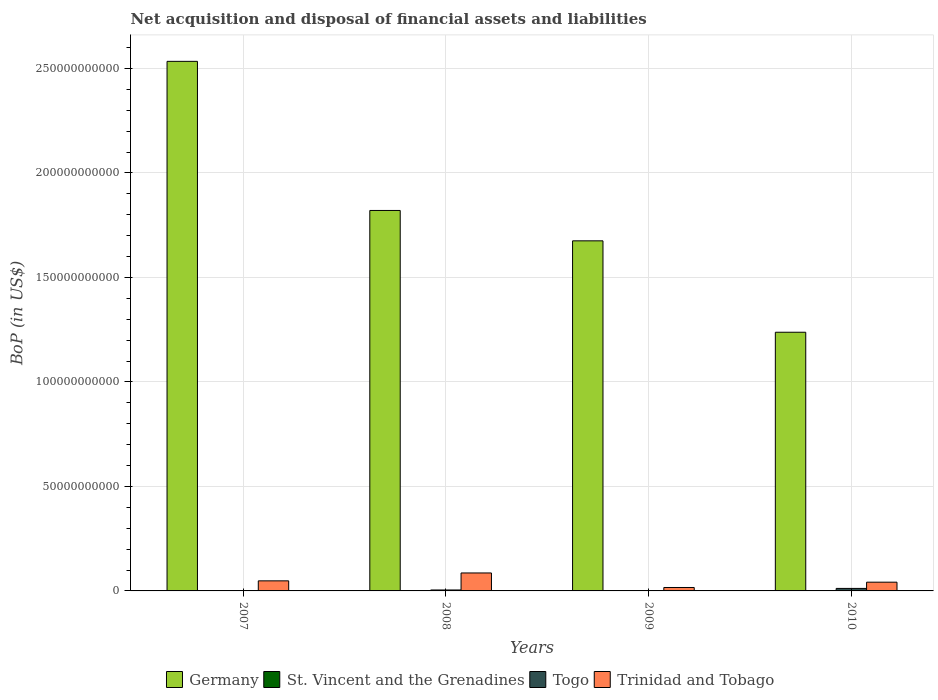Are the number of bars on each tick of the X-axis equal?
Offer a terse response. No. How many bars are there on the 3rd tick from the left?
Make the answer very short. 2. Across all years, what is the maximum Balance of Payments in Trinidad and Tobago?
Provide a short and direct response. 8.60e+09. Across all years, what is the minimum Balance of Payments in St. Vincent and the Grenadines?
Ensure brevity in your answer.  0. In which year was the Balance of Payments in Trinidad and Tobago maximum?
Offer a very short reply. 2008. What is the total Balance of Payments in Togo in the graph?
Make the answer very short. 1.65e+09. What is the difference between the Balance of Payments in Trinidad and Tobago in 2007 and that in 2008?
Give a very brief answer. -3.77e+09. What is the difference between the Balance of Payments in Togo in 2007 and the Balance of Payments in Germany in 2008?
Offer a terse response. -1.82e+11. What is the average Balance of Payments in Togo per year?
Provide a succinct answer. 4.13e+08. In the year 2008, what is the difference between the Balance of Payments in Togo and Balance of Payments in Trinidad and Tobago?
Make the answer very short. -8.14e+09. In how many years, is the Balance of Payments in Trinidad and Tobago greater than 60000000000 US$?
Give a very brief answer. 0. What is the ratio of the Balance of Payments in Germany in 2008 to that in 2009?
Provide a succinct answer. 1.09. What is the difference between the highest and the second highest Balance of Payments in Germany?
Offer a terse response. 7.13e+1. What is the difference between the highest and the lowest Balance of Payments in Germany?
Offer a very short reply. 1.30e+11. In how many years, is the Balance of Payments in St. Vincent and the Grenadines greater than the average Balance of Payments in St. Vincent and the Grenadines taken over all years?
Make the answer very short. 0. Is the sum of the Balance of Payments in Togo in 2008 and 2010 greater than the maximum Balance of Payments in Trinidad and Tobago across all years?
Your answer should be compact. No. Is it the case that in every year, the sum of the Balance of Payments in Togo and Balance of Payments in Germany is greater than the sum of Balance of Payments in St. Vincent and the Grenadines and Balance of Payments in Trinidad and Tobago?
Your answer should be very brief. Yes. Is it the case that in every year, the sum of the Balance of Payments in Togo and Balance of Payments in Trinidad and Tobago is greater than the Balance of Payments in St. Vincent and the Grenadines?
Make the answer very short. Yes. How many bars are there?
Your answer should be very brief. 10. Are all the bars in the graph horizontal?
Ensure brevity in your answer.  No. How many years are there in the graph?
Your answer should be very brief. 4. Where does the legend appear in the graph?
Ensure brevity in your answer.  Bottom center. How many legend labels are there?
Make the answer very short. 4. How are the legend labels stacked?
Make the answer very short. Horizontal. What is the title of the graph?
Your answer should be compact. Net acquisition and disposal of financial assets and liabilities. What is the label or title of the X-axis?
Provide a succinct answer. Years. What is the label or title of the Y-axis?
Give a very brief answer. BoP (in US$). What is the BoP (in US$) of Germany in 2007?
Offer a very short reply. 2.53e+11. What is the BoP (in US$) of St. Vincent and the Grenadines in 2007?
Provide a short and direct response. 0. What is the BoP (in US$) of Trinidad and Tobago in 2007?
Your response must be concise. 4.82e+09. What is the BoP (in US$) of Germany in 2008?
Your response must be concise. 1.82e+11. What is the BoP (in US$) of St. Vincent and the Grenadines in 2008?
Ensure brevity in your answer.  0. What is the BoP (in US$) in Togo in 2008?
Give a very brief answer. 4.53e+08. What is the BoP (in US$) in Trinidad and Tobago in 2008?
Offer a very short reply. 8.60e+09. What is the BoP (in US$) in Germany in 2009?
Provide a succinct answer. 1.68e+11. What is the BoP (in US$) of Trinidad and Tobago in 2009?
Your answer should be very brief. 1.64e+09. What is the BoP (in US$) in Germany in 2010?
Your response must be concise. 1.24e+11. What is the BoP (in US$) in St. Vincent and the Grenadines in 2010?
Your answer should be compact. 0. What is the BoP (in US$) in Togo in 2010?
Offer a very short reply. 1.20e+09. What is the BoP (in US$) in Trinidad and Tobago in 2010?
Give a very brief answer. 4.18e+09. Across all years, what is the maximum BoP (in US$) in Germany?
Ensure brevity in your answer.  2.53e+11. Across all years, what is the maximum BoP (in US$) in Togo?
Your answer should be compact. 1.20e+09. Across all years, what is the maximum BoP (in US$) of Trinidad and Tobago?
Keep it short and to the point. 8.60e+09. Across all years, what is the minimum BoP (in US$) in Germany?
Ensure brevity in your answer.  1.24e+11. Across all years, what is the minimum BoP (in US$) in Trinidad and Tobago?
Your response must be concise. 1.64e+09. What is the total BoP (in US$) in Germany in the graph?
Make the answer very short. 7.27e+11. What is the total BoP (in US$) of St. Vincent and the Grenadines in the graph?
Offer a very short reply. 0. What is the total BoP (in US$) in Togo in the graph?
Ensure brevity in your answer.  1.65e+09. What is the total BoP (in US$) in Trinidad and Tobago in the graph?
Make the answer very short. 1.92e+1. What is the difference between the BoP (in US$) of Germany in 2007 and that in 2008?
Offer a terse response. 7.13e+1. What is the difference between the BoP (in US$) in Trinidad and Tobago in 2007 and that in 2008?
Ensure brevity in your answer.  -3.77e+09. What is the difference between the BoP (in US$) of Germany in 2007 and that in 2009?
Keep it short and to the point. 8.59e+1. What is the difference between the BoP (in US$) in Trinidad and Tobago in 2007 and that in 2009?
Your answer should be compact. 3.18e+09. What is the difference between the BoP (in US$) in Germany in 2007 and that in 2010?
Provide a succinct answer. 1.30e+11. What is the difference between the BoP (in US$) in Trinidad and Tobago in 2007 and that in 2010?
Offer a terse response. 6.40e+08. What is the difference between the BoP (in US$) of Germany in 2008 and that in 2009?
Your answer should be very brief. 1.45e+1. What is the difference between the BoP (in US$) in Trinidad and Tobago in 2008 and that in 2009?
Give a very brief answer. 6.96e+09. What is the difference between the BoP (in US$) in Germany in 2008 and that in 2010?
Offer a very short reply. 5.83e+1. What is the difference between the BoP (in US$) of Togo in 2008 and that in 2010?
Provide a short and direct response. -7.46e+08. What is the difference between the BoP (in US$) of Trinidad and Tobago in 2008 and that in 2010?
Your response must be concise. 4.42e+09. What is the difference between the BoP (in US$) of Germany in 2009 and that in 2010?
Give a very brief answer. 4.37e+1. What is the difference between the BoP (in US$) in Trinidad and Tobago in 2009 and that in 2010?
Offer a terse response. -2.54e+09. What is the difference between the BoP (in US$) in Germany in 2007 and the BoP (in US$) in Togo in 2008?
Offer a very short reply. 2.53e+11. What is the difference between the BoP (in US$) of Germany in 2007 and the BoP (in US$) of Trinidad and Tobago in 2008?
Give a very brief answer. 2.45e+11. What is the difference between the BoP (in US$) of Germany in 2007 and the BoP (in US$) of Trinidad and Tobago in 2009?
Provide a short and direct response. 2.52e+11. What is the difference between the BoP (in US$) of Germany in 2007 and the BoP (in US$) of Togo in 2010?
Give a very brief answer. 2.52e+11. What is the difference between the BoP (in US$) in Germany in 2007 and the BoP (in US$) in Trinidad and Tobago in 2010?
Your answer should be compact. 2.49e+11. What is the difference between the BoP (in US$) in Germany in 2008 and the BoP (in US$) in Trinidad and Tobago in 2009?
Offer a very short reply. 1.80e+11. What is the difference between the BoP (in US$) of Togo in 2008 and the BoP (in US$) of Trinidad and Tobago in 2009?
Keep it short and to the point. -1.19e+09. What is the difference between the BoP (in US$) of Germany in 2008 and the BoP (in US$) of Togo in 2010?
Ensure brevity in your answer.  1.81e+11. What is the difference between the BoP (in US$) in Germany in 2008 and the BoP (in US$) in Trinidad and Tobago in 2010?
Keep it short and to the point. 1.78e+11. What is the difference between the BoP (in US$) of Togo in 2008 and the BoP (in US$) of Trinidad and Tobago in 2010?
Provide a short and direct response. -3.73e+09. What is the difference between the BoP (in US$) of Germany in 2009 and the BoP (in US$) of Togo in 2010?
Provide a succinct answer. 1.66e+11. What is the difference between the BoP (in US$) of Germany in 2009 and the BoP (in US$) of Trinidad and Tobago in 2010?
Make the answer very short. 1.63e+11. What is the average BoP (in US$) in Germany per year?
Offer a terse response. 1.82e+11. What is the average BoP (in US$) in St. Vincent and the Grenadines per year?
Provide a short and direct response. 0. What is the average BoP (in US$) in Togo per year?
Your answer should be very brief. 4.13e+08. What is the average BoP (in US$) of Trinidad and Tobago per year?
Provide a succinct answer. 4.81e+09. In the year 2007, what is the difference between the BoP (in US$) of Germany and BoP (in US$) of Trinidad and Tobago?
Your answer should be compact. 2.49e+11. In the year 2008, what is the difference between the BoP (in US$) in Germany and BoP (in US$) in Togo?
Offer a terse response. 1.82e+11. In the year 2008, what is the difference between the BoP (in US$) of Germany and BoP (in US$) of Trinidad and Tobago?
Your response must be concise. 1.73e+11. In the year 2008, what is the difference between the BoP (in US$) of Togo and BoP (in US$) of Trinidad and Tobago?
Provide a succinct answer. -8.14e+09. In the year 2009, what is the difference between the BoP (in US$) in Germany and BoP (in US$) in Trinidad and Tobago?
Ensure brevity in your answer.  1.66e+11. In the year 2010, what is the difference between the BoP (in US$) of Germany and BoP (in US$) of Togo?
Give a very brief answer. 1.23e+11. In the year 2010, what is the difference between the BoP (in US$) of Germany and BoP (in US$) of Trinidad and Tobago?
Offer a very short reply. 1.20e+11. In the year 2010, what is the difference between the BoP (in US$) in Togo and BoP (in US$) in Trinidad and Tobago?
Keep it short and to the point. -2.98e+09. What is the ratio of the BoP (in US$) in Germany in 2007 to that in 2008?
Your response must be concise. 1.39. What is the ratio of the BoP (in US$) in Trinidad and Tobago in 2007 to that in 2008?
Offer a very short reply. 0.56. What is the ratio of the BoP (in US$) of Germany in 2007 to that in 2009?
Provide a short and direct response. 1.51. What is the ratio of the BoP (in US$) in Trinidad and Tobago in 2007 to that in 2009?
Your answer should be very brief. 2.94. What is the ratio of the BoP (in US$) in Germany in 2007 to that in 2010?
Keep it short and to the point. 2.05. What is the ratio of the BoP (in US$) in Trinidad and Tobago in 2007 to that in 2010?
Ensure brevity in your answer.  1.15. What is the ratio of the BoP (in US$) in Germany in 2008 to that in 2009?
Your answer should be very brief. 1.09. What is the ratio of the BoP (in US$) of Trinidad and Tobago in 2008 to that in 2009?
Give a very brief answer. 5.24. What is the ratio of the BoP (in US$) in Germany in 2008 to that in 2010?
Your answer should be very brief. 1.47. What is the ratio of the BoP (in US$) of Togo in 2008 to that in 2010?
Ensure brevity in your answer.  0.38. What is the ratio of the BoP (in US$) in Trinidad and Tobago in 2008 to that in 2010?
Your response must be concise. 2.06. What is the ratio of the BoP (in US$) of Germany in 2009 to that in 2010?
Offer a terse response. 1.35. What is the ratio of the BoP (in US$) of Trinidad and Tobago in 2009 to that in 2010?
Your answer should be compact. 0.39. What is the difference between the highest and the second highest BoP (in US$) in Germany?
Make the answer very short. 7.13e+1. What is the difference between the highest and the second highest BoP (in US$) in Trinidad and Tobago?
Provide a short and direct response. 3.77e+09. What is the difference between the highest and the lowest BoP (in US$) in Germany?
Keep it short and to the point. 1.30e+11. What is the difference between the highest and the lowest BoP (in US$) in Togo?
Ensure brevity in your answer.  1.20e+09. What is the difference between the highest and the lowest BoP (in US$) in Trinidad and Tobago?
Provide a short and direct response. 6.96e+09. 